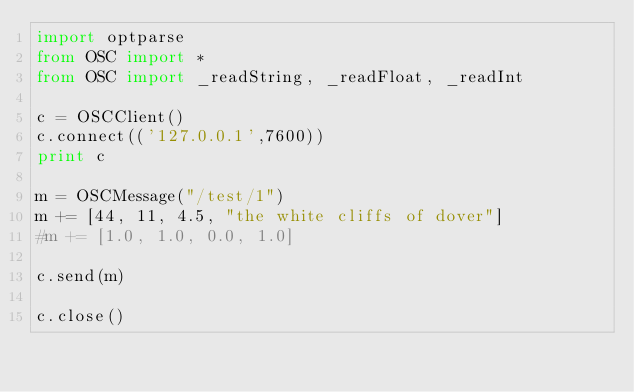<code> <loc_0><loc_0><loc_500><loc_500><_Python_>import optparse
from OSC import *
from OSC import _readString, _readFloat, _readInt

c = OSCClient()
c.connect(('127.0.0.1',7600))
print c

m = OSCMessage("/test/1")
m += [44, 11, 4.5, "the white cliffs of dover"]
#m += [1.0, 1.0, 0.0, 1.0]

c.send(m)

c.close()
</code> 